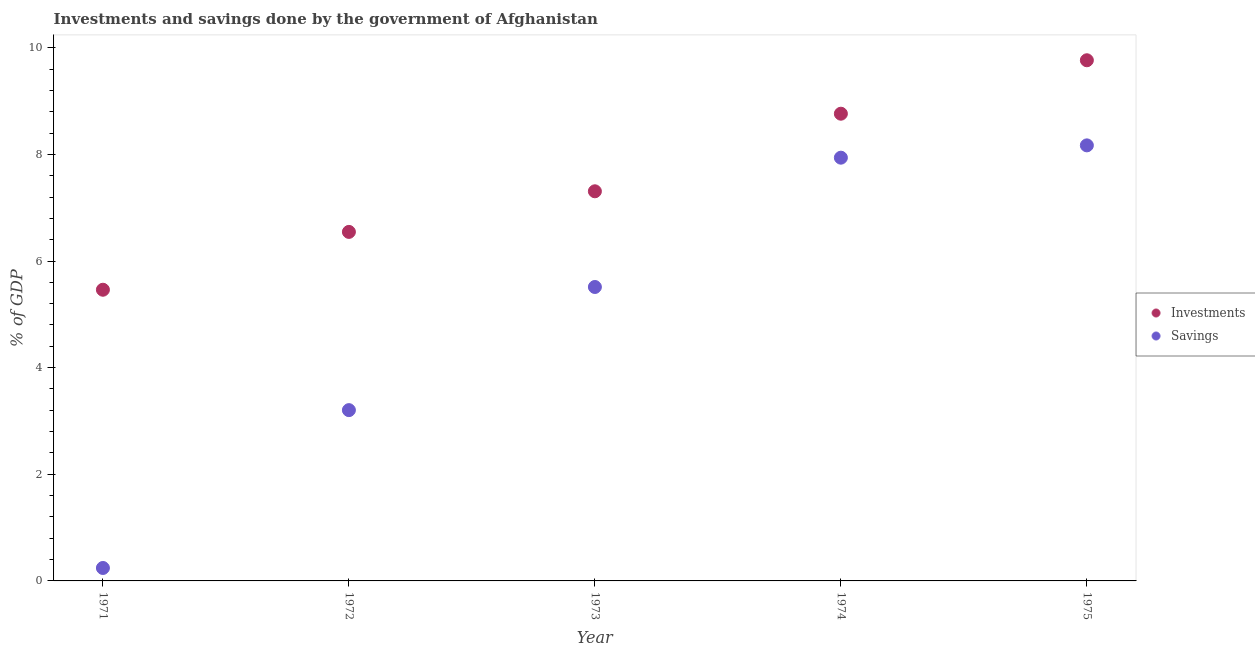What is the investments of government in 1972?
Your answer should be very brief. 6.55. Across all years, what is the maximum savings of government?
Offer a terse response. 8.17. Across all years, what is the minimum investments of government?
Provide a succinct answer. 5.46. In which year was the savings of government maximum?
Your answer should be compact. 1975. What is the total savings of government in the graph?
Offer a very short reply. 25.07. What is the difference between the investments of government in 1971 and that in 1974?
Ensure brevity in your answer.  -3.3. What is the difference between the investments of government in 1975 and the savings of government in 1974?
Ensure brevity in your answer.  1.83. What is the average investments of government per year?
Your answer should be compact. 7.57. In the year 1973, what is the difference between the savings of government and investments of government?
Give a very brief answer. -1.79. What is the ratio of the investments of government in 1974 to that in 1975?
Make the answer very short. 0.9. Is the investments of government in 1971 less than that in 1975?
Your response must be concise. Yes. Is the difference between the savings of government in 1972 and 1974 greater than the difference between the investments of government in 1972 and 1974?
Your response must be concise. No. What is the difference between the highest and the second highest investments of government?
Keep it short and to the point. 1. What is the difference between the highest and the lowest savings of government?
Ensure brevity in your answer.  7.93. In how many years, is the savings of government greater than the average savings of government taken over all years?
Your response must be concise. 3. Is the investments of government strictly less than the savings of government over the years?
Your answer should be compact. No. How many dotlines are there?
Offer a terse response. 2. How many years are there in the graph?
Your response must be concise. 5. Are the values on the major ticks of Y-axis written in scientific E-notation?
Provide a succinct answer. No. Does the graph contain any zero values?
Your answer should be compact. No. Does the graph contain grids?
Your answer should be very brief. No. What is the title of the graph?
Provide a short and direct response. Investments and savings done by the government of Afghanistan. Does "Quasi money growth" appear as one of the legend labels in the graph?
Your answer should be very brief. No. What is the label or title of the X-axis?
Make the answer very short. Year. What is the label or title of the Y-axis?
Provide a short and direct response. % of GDP. What is the % of GDP in Investments in 1971?
Provide a short and direct response. 5.46. What is the % of GDP of Savings in 1971?
Offer a terse response. 0.24. What is the % of GDP of Investments in 1972?
Make the answer very short. 6.55. What is the % of GDP in Savings in 1972?
Give a very brief answer. 3.2. What is the % of GDP in Investments in 1973?
Your answer should be compact. 7.31. What is the % of GDP in Savings in 1973?
Your answer should be very brief. 5.51. What is the % of GDP of Investments in 1974?
Provide a short and direct response. 8.76. What is the % of GDP of Savings in 1974?
Provide a succinct answer. 7.94. What is the % of GDP of Investments in 1975?
Keep it short and to the point. 9.77. What is the % of GDP of Savings in 1975?
Your response must be concise. 8.17. Across all years, what is the maximum % of GDP of Investments?
Your answer should be compact. 9.77. Across all years, what is the maximum % of GDP in Savings?
Keep it short and to the point. 8.17. Across all years, what is the minimum % of GDP in Investments?
Give a very brief answer. 5.46. Across all years, what is the minimum % of GDP in Savings?
Keep it short and to the point. 0.24. What is the total % of GDP of Investments in the graph?
Your response must be concise. 37.84. What is the total % of GDP of Savings in the graph?
Give a very brief answer. 25.07. What is the difference between the % of GDP in Investments in 1971 and that in 1972?
Provide a succinct answer. -1.08. What is the difference between the % of GDP of Savings in 1971 and that in 1972?
Keep it short and to the point. -2.96. What is the difference between the % of GDP in Investments in 1971 and that in 1973?
Offer a terse response. -1.85. What is the difference between the % of GDP of Savings in 1971 and that in 1973?
Offer a very short reply. -5.27. What is the difference between the % of GDP of Investments in 1971 and that in 1974?
Make the answer very short. -3.3. What is the difference between the % of GDP in Savings in 1971 and that in 1974?
Ensure brevity in your answer.  -7.7. What is the difference between the % of GDP of Investments in 1971 and that in 1975?
Offer a terse response. -4.3. What is the difference between the % of GDP in Savings in 1971 and that in 1975?
Give a very brief answer. -7.93. What is the difference between the % of GDP of Investments in 1972 and that in 1973?
Offer a terse response. -0.76. What is the difference between the % of GDP of Savings in 1972 and that in 1973?
Keep it short and to the point. -2.31. What is the difference between the % of GDP of Investments in 1972 and that in 1974?
Your answer should be compact. -2.22. What is the difference between the % of GDP of Savings in 1972 and that in 1974?
Ensure brevity in your answer.  -4.73. What is the difference between the % of GDP of Investments in 1972 and that in 1975?
Your answer should be very brief. -3.22. What is the difference between the % of GDP in Savings in 1972 and that in 1975?
Provide a succinct answer. -4.97. What is the difference between the % of GDP of Investments in 1973 and that in 1974?
Offer a very short reply. -1.46. What is the difference between the % of GDP of Savings in 1973 and that in 1974?
Keep it short and to the point. -2.43. What is the difference between the % of GDP of Investments in 1973 and that in 1975?
Make the answer very short. -2.46. What is the difference between the % of GDP of Savings in 1973 and that in 1975?
Offer a very short reply. -2.66. What is the difference between the % of GDP of Investments in 1974 and that in 1975?
Your response must be concise. -1. What is the difference between the % of GDP of Savings in 1974 and that in 1975?
Make the answer very short. -0.23. What is the difference between the % of GDP of Investments in 1971 and the % of GDP of Savings in 1972?
Provide a succinct answer. 2.26. What is the difference between the % of GDP in Investments in 1971 and the % of GDP in Savings in 1973?
Make the answer very short. -0.05. What is the difference between the % of GDP of Investments in 1971 and the % of GDP of Savings in 1974?
Keep it short and to the point. -2.48. What is the difference between the % of GDP of Investments in 1971 and the % of GDP of Savings in 1975?
Ensure brevity in your answer.  -2.71. What is the difference between the % of GDP of Investments in 1972 and the % of GDP of Savings in 1973?
Your response must be concise. 1.03. What is the difference between the % of GDP of Investments in 1972 and the % of GDP of Savings in 1974?
Keep it short and to the point. -1.39. What is the difference between the % of GDP in Investments in 1972 and the % of GDP in Savings in 1975?
Keep it short and to the point. -1.62. What is the difference between the % of GDP of Investments in 1973 and the % of GDP of Savings in 1974?
Your answer should be very brief. -0.63. What is the difference between the % of GDP in Investments in 1973 and the % of GDP in Savings in 1975?
Make the answer very short. -0.86. What is the difference between the % of GDP of Investments in 1974 and the % of GDP of Savings in 1975?
Make the answer very short. 0.59. What is the average % of GDP in Investments per year?
Ensure brevity in your answer.  7.57. What is the average % of GDP in Savings per year?
Give a very brief answer. 5.01. In the year 1971, what is the difference between the % of GDP in Investments and % of GDP in Savings?
Your answer should be very brief. 5.22. In the year 1972, what is the difference between the % of GDP of Investments and % of GDP of Savings?
Your response must be concise. 3.34. In the year 1973, what is the difference between the % of GDP in Investments and % of GDP in Savings?
Offer a very short reply. 1.79. In the year 1974, what is the difference between the % of GDP in Investments and % of GDP in Savings?
Your response must be concise. 0.82. In the year 1975, what is the difference between the % of GDP in Investments and % of GDP in Savings?
Offer a very short reply. 1.6. What is the ratio of the % of GDP in Investments in 1971 to that in 1972?
Provide a short and direct response. 0.83. What is the ratio of the % of GDP in Savings in 1971 to that in 1972?
Give a very brief answer. 0.08. What is the ratio of the % of GDP of Investments in 1971 to that in 1973?
Your answer should be compact. 0.75. What is the ratio of the % of GDP of Savings in 1971 to that in 1973?
Provide a succinct answer. 0.04. What is the ratio of the % of GDP in Investments in 1971 to that in 1974?
Provide a short and direct response. 0.62. What is the ratio of the % of GDP in Savings in 1971 to that in 1974?
Offer a terse response. 0.03. What is the ratio of the % of GDP in Investments in 1971 to that in 1975?
Your answer should be compact. 0.56. What is the ratio of the % of GDP in Savings in 1971 to that in 1975?
Make the answer very short. 0.03. What is the ratio of the % of GDP in Investments in 1972 to that in 1973?
Your answer should be compact. 0.9. What is the ratio of the % of GDP in Savings in 1972 to that in 1973?
Keep it short and to the point. 0.58. What is the ratio of the % of GDP in Investments in 1972 to that in 1974?
Provide a succinct answer. 0.75. What is the ratio of the % of GDP of Savings in 1972 to that in 1974?
Offer a very short reply. 0.4. What is the ratio of the % of GDP in Investments in 1972 to that in 1975?
Provide a short and direct response. 0.67. What is the ratio of the % of GDP of Savings in 1972 to that in 1975?
Ensure brevity in your answer.  0.39. What is the ratio of the % of GDP in Investments in 1973 to that in 1974?
Ensure brevity in your answer.  0.83. What is the ratio of the % of GDP in Savings in 1973 to that in 1974?
Keep it short and to the point. 0.69. What is the ratio of the % of GDP of Investments in 1973 to that in 1975?
Ensure brevity in your answer.  0.75. What is the ratio of the % of GDP of Savings in 1973 to that in 1975?
Provide a succinct answer. 0.67. What is the ratio of the % of GDP in Investments in 1974 to that in 1975?
Ensure brevity in your answer.  0.9. What is the ratio of the % of GDP of Savings in 1974 to that in 1975?
Your answer should be very brief. 0.97. What is the difference between the highest and the second highest % of GDP of Savings?
Ensure brevity in your answer.  0.23. What is the difference between the highest and the lowest % of GDP in Investments?
Keep it short and to the point. 4.3. What is the difference between the highest and the lowest % of GDP in Savings?
Keep it short and to the point. 7.93. 